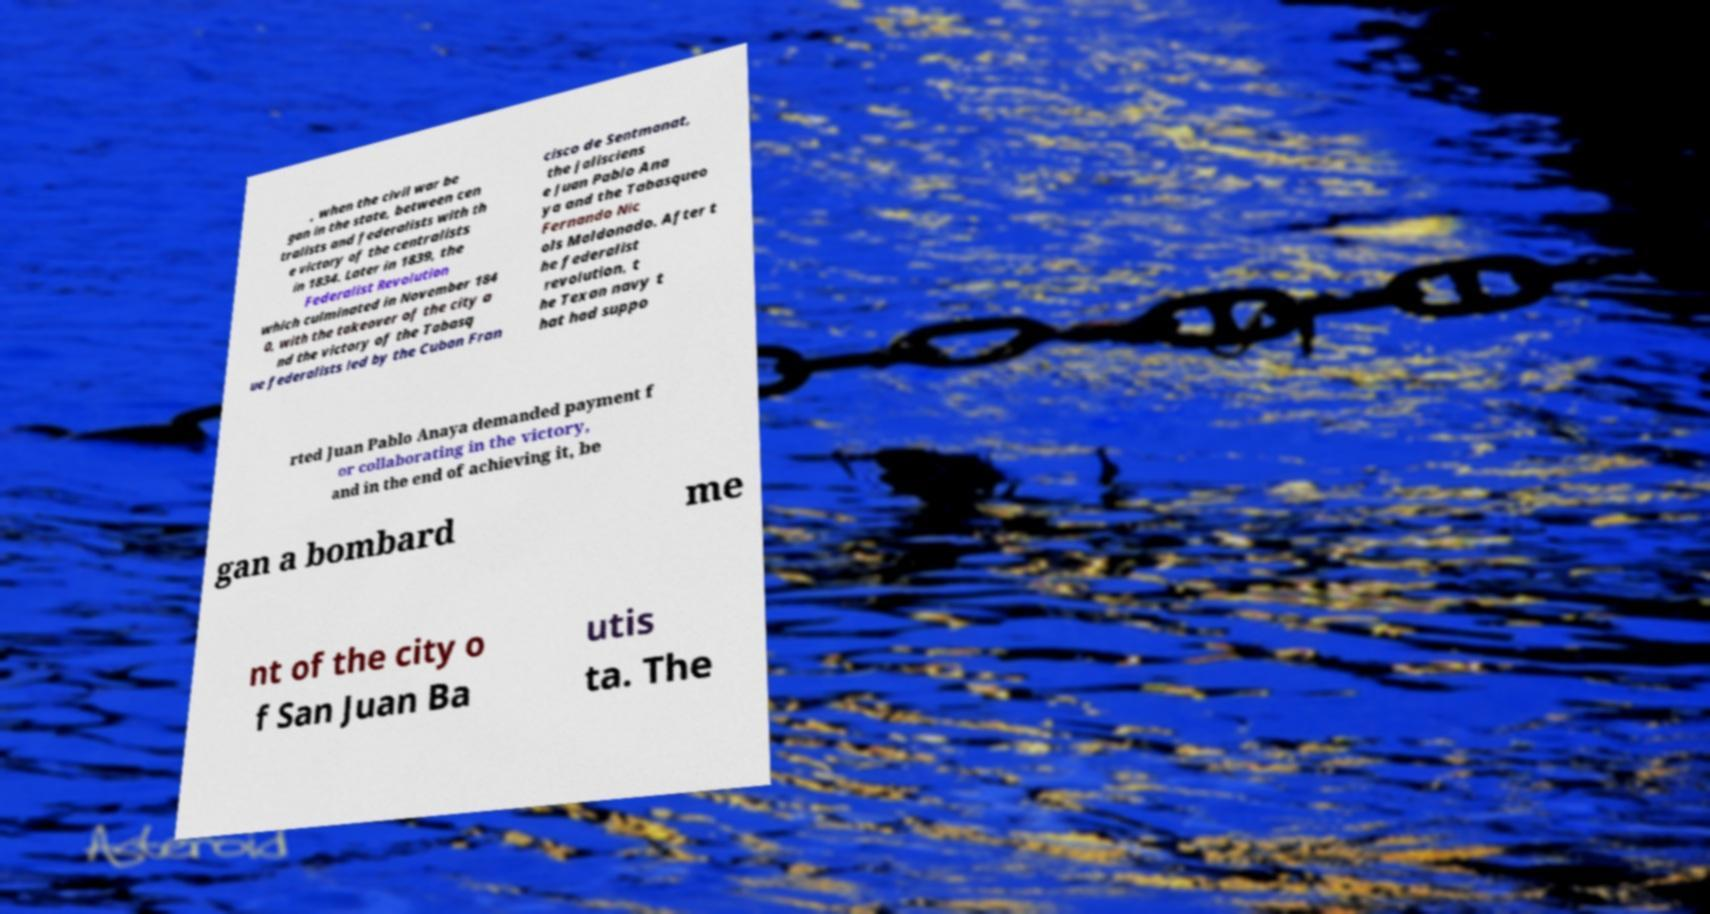Please read and relay the text visible in this image. What does it say? , when the civil war be gan in the state, between cen tralists and federalists with th e victory of the centralists in 1834. Later in 1839, the Federalist Revolution which culminated in November 184 0, with the takeover of the city a nd the victory of the Tabasq ue federalists led by the Cuban Fran cisco de Sentmanat, the jalisciens e Juan Pablo Ana ya and the Tabasqueo Fernando Nic ols Maldonado. After t he federalist revolution, t he Texan navy t hat had suppo rted Juan Pablo Anaya demanded payment f or collaborating in the victory, and in the end of achieving it, be gan a bombard me nt of the city o f San Juan Ba utis ta. The 